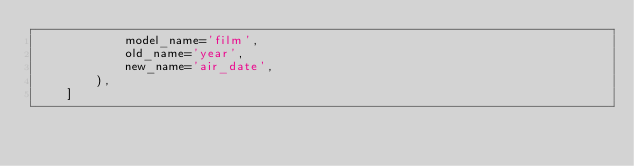<code> <loc_0><loc_0><loc_500><loc_500><_Python_>            model_name='film',
            old_name='year',
            new_name='air_date',
        ),
    ]
</code> 